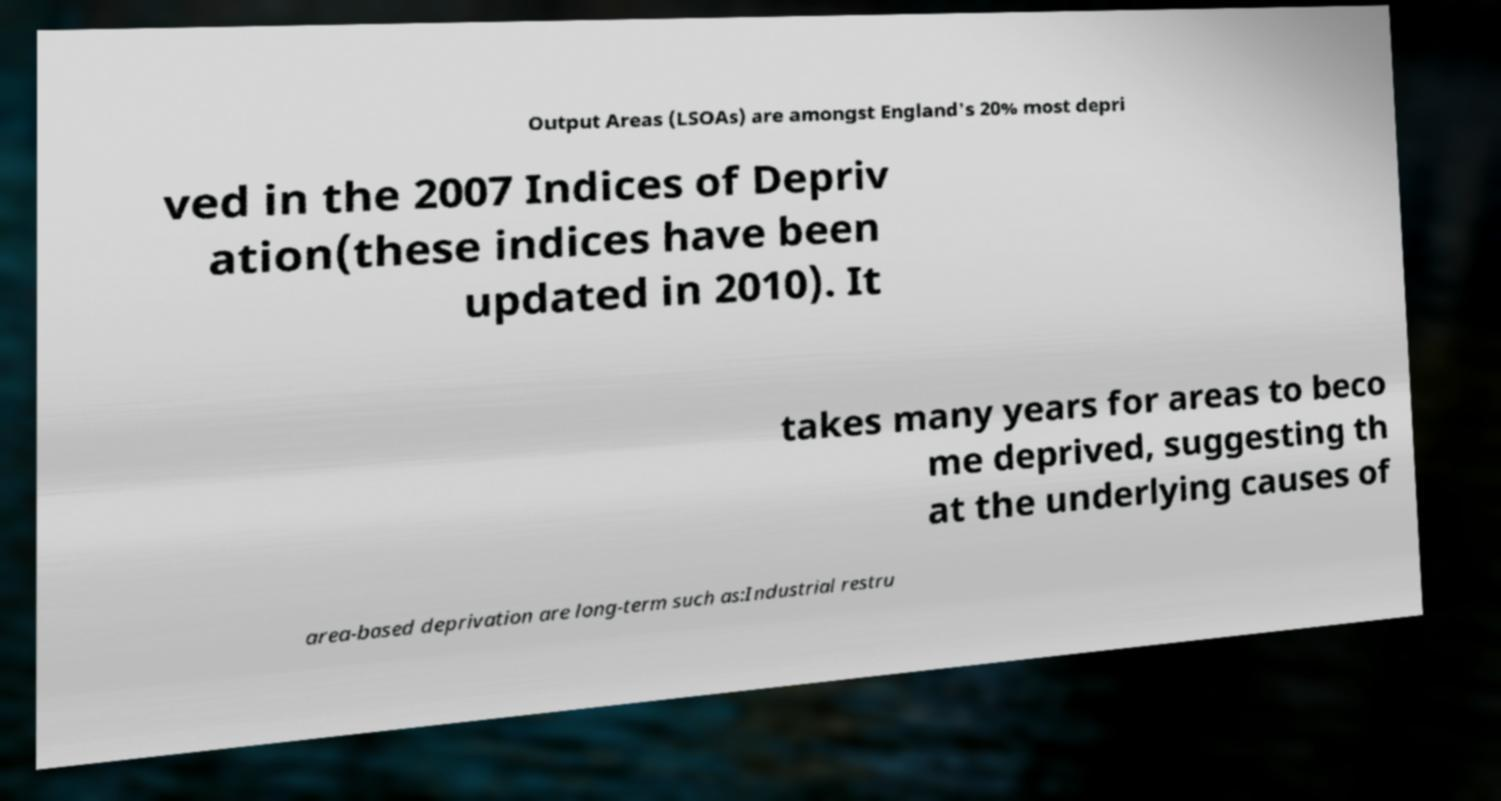Please identify and transcribe the text found in this image. Output Areas (LSOAs) are amongst England's 20% most depri ved in the 2007 Indices of Depriv ation(these indices have been updated in 2010). It takes many years for areas to beco me deprived, suggesting th at the underlying causes of area-based deprivation are long-term such as:Industrial restru 